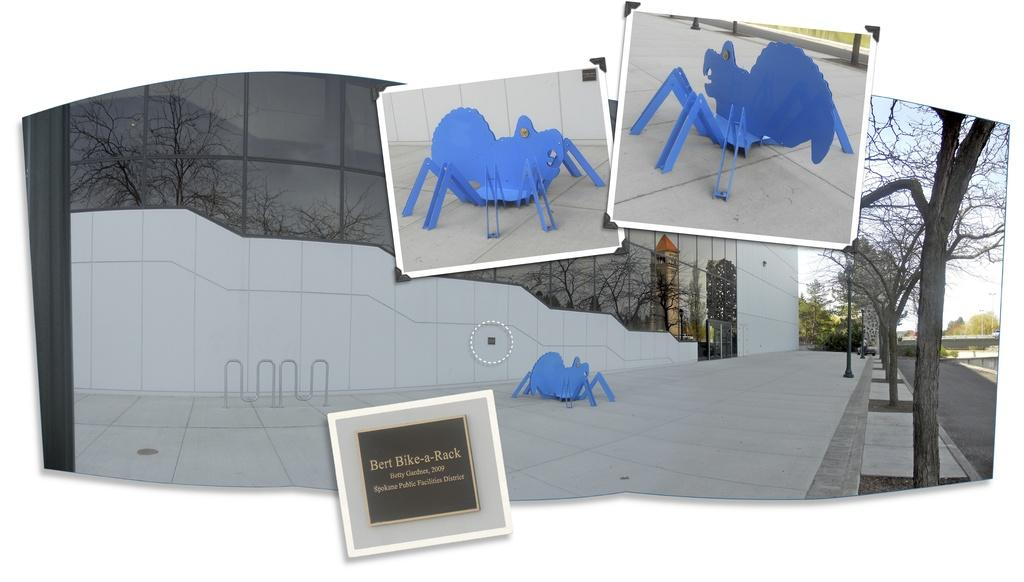<image>
Render a clear and concise summary of the photo. A spider statue sits next to a plaque that says Bert Bike-a-Rack. 